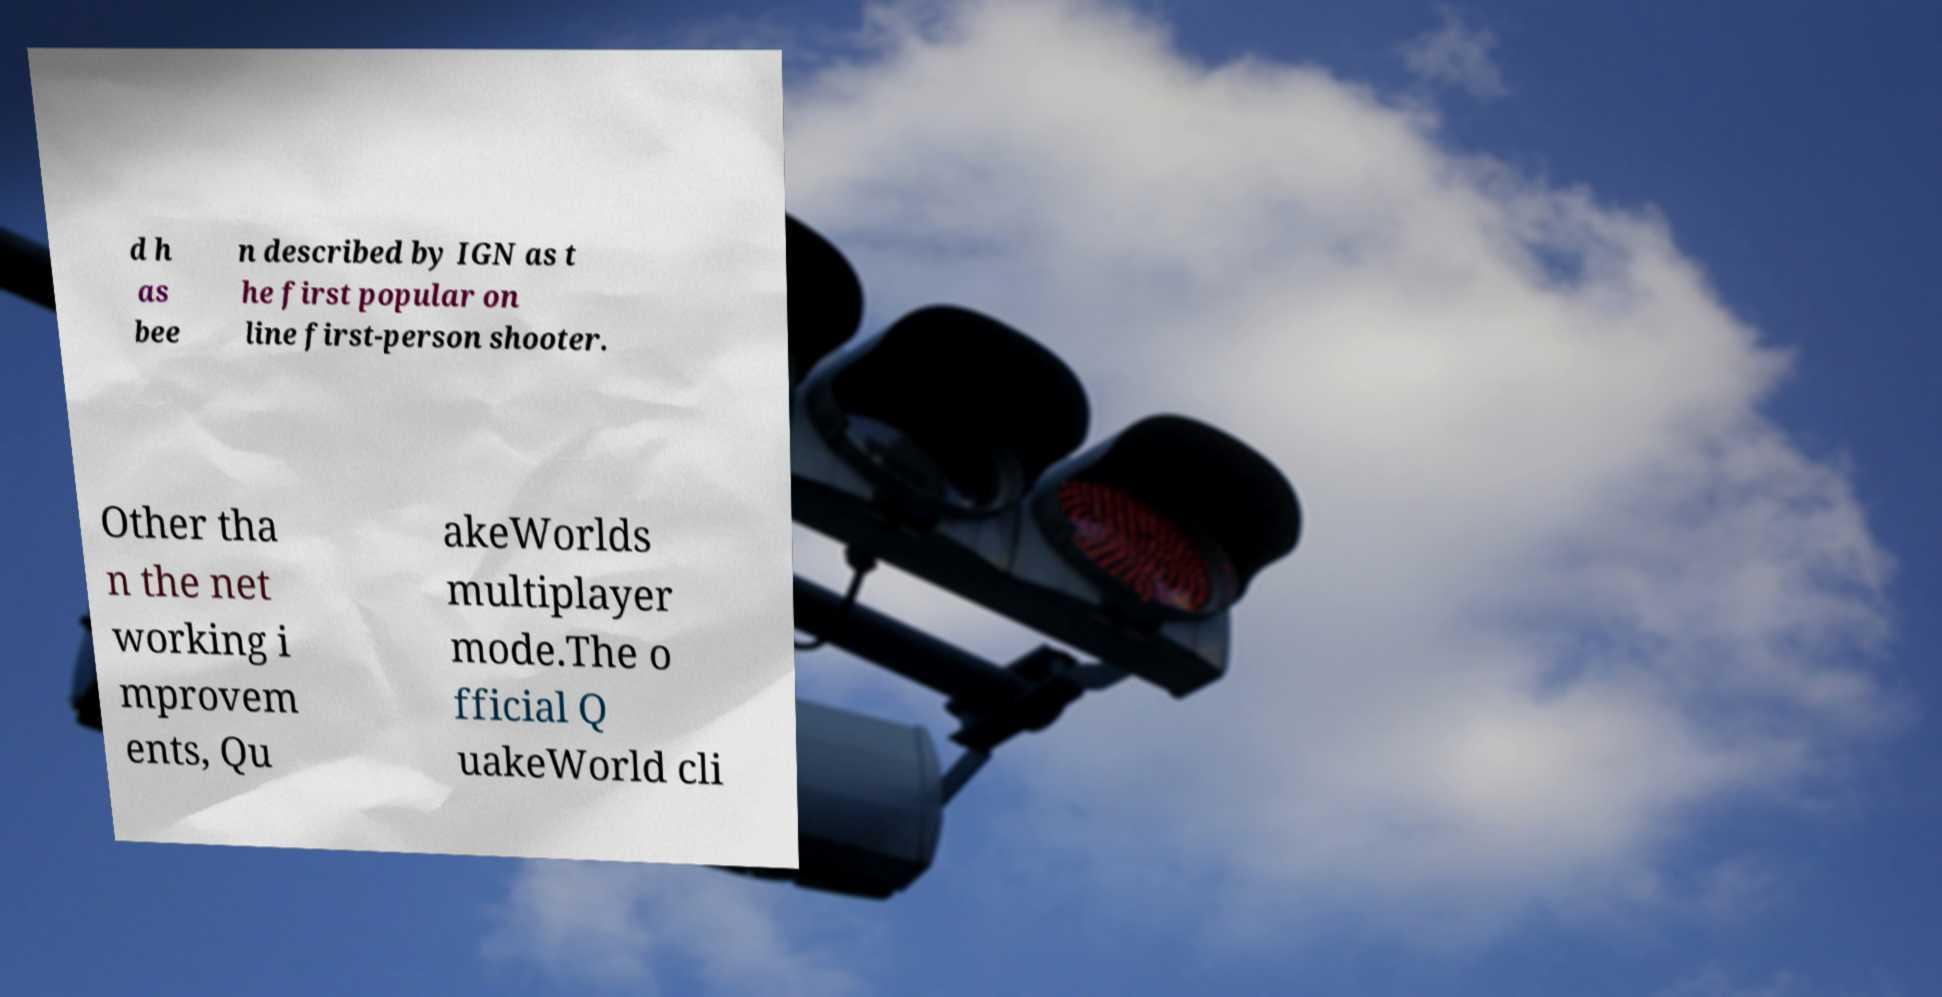What messages or text are displayed in this image? I need them in a readable, typed format. d h as bee n described by IGN as t he first popular on line first-person shooter. Other tha n the net working i mprovem ents, Qu akeWorlds multiplayer mode.The o fficial Q uakeWorld cli 